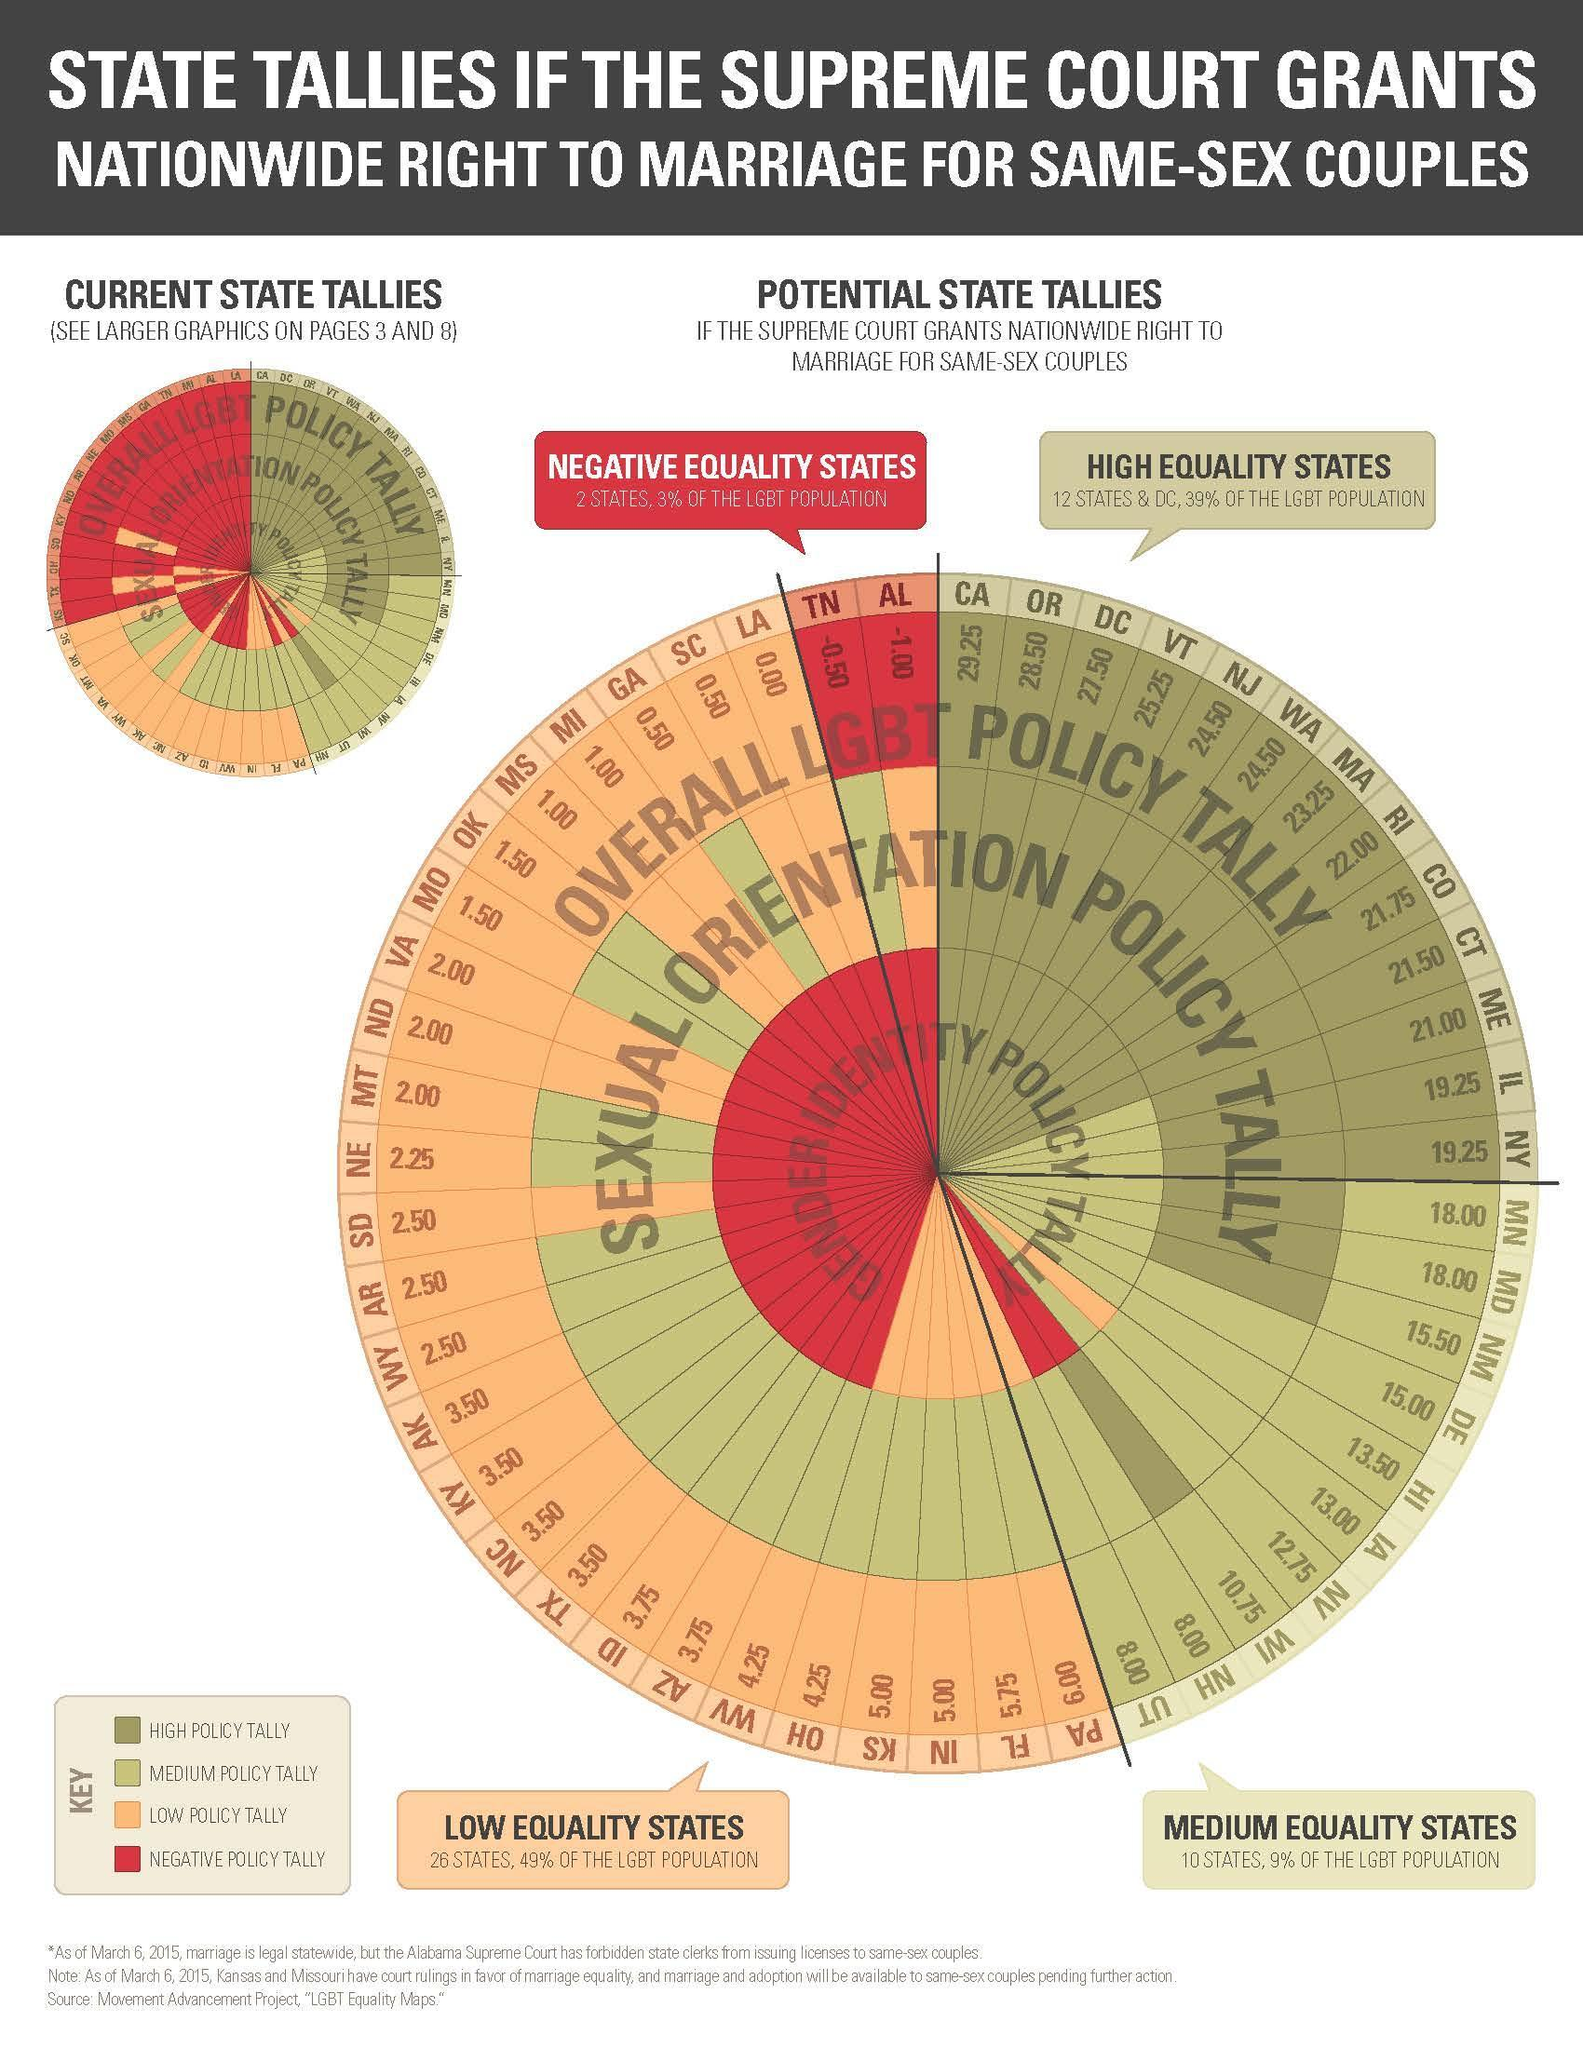According to the key, what parameter is represented by red colour?
Answer the question with a short phrase. NEGATIVE POLICY TALLY By what colour is low policy tally represented- yellow, red or blue? yellow Which states are negative equality? TN, AL How many high equality and medium equality states are given? 22 